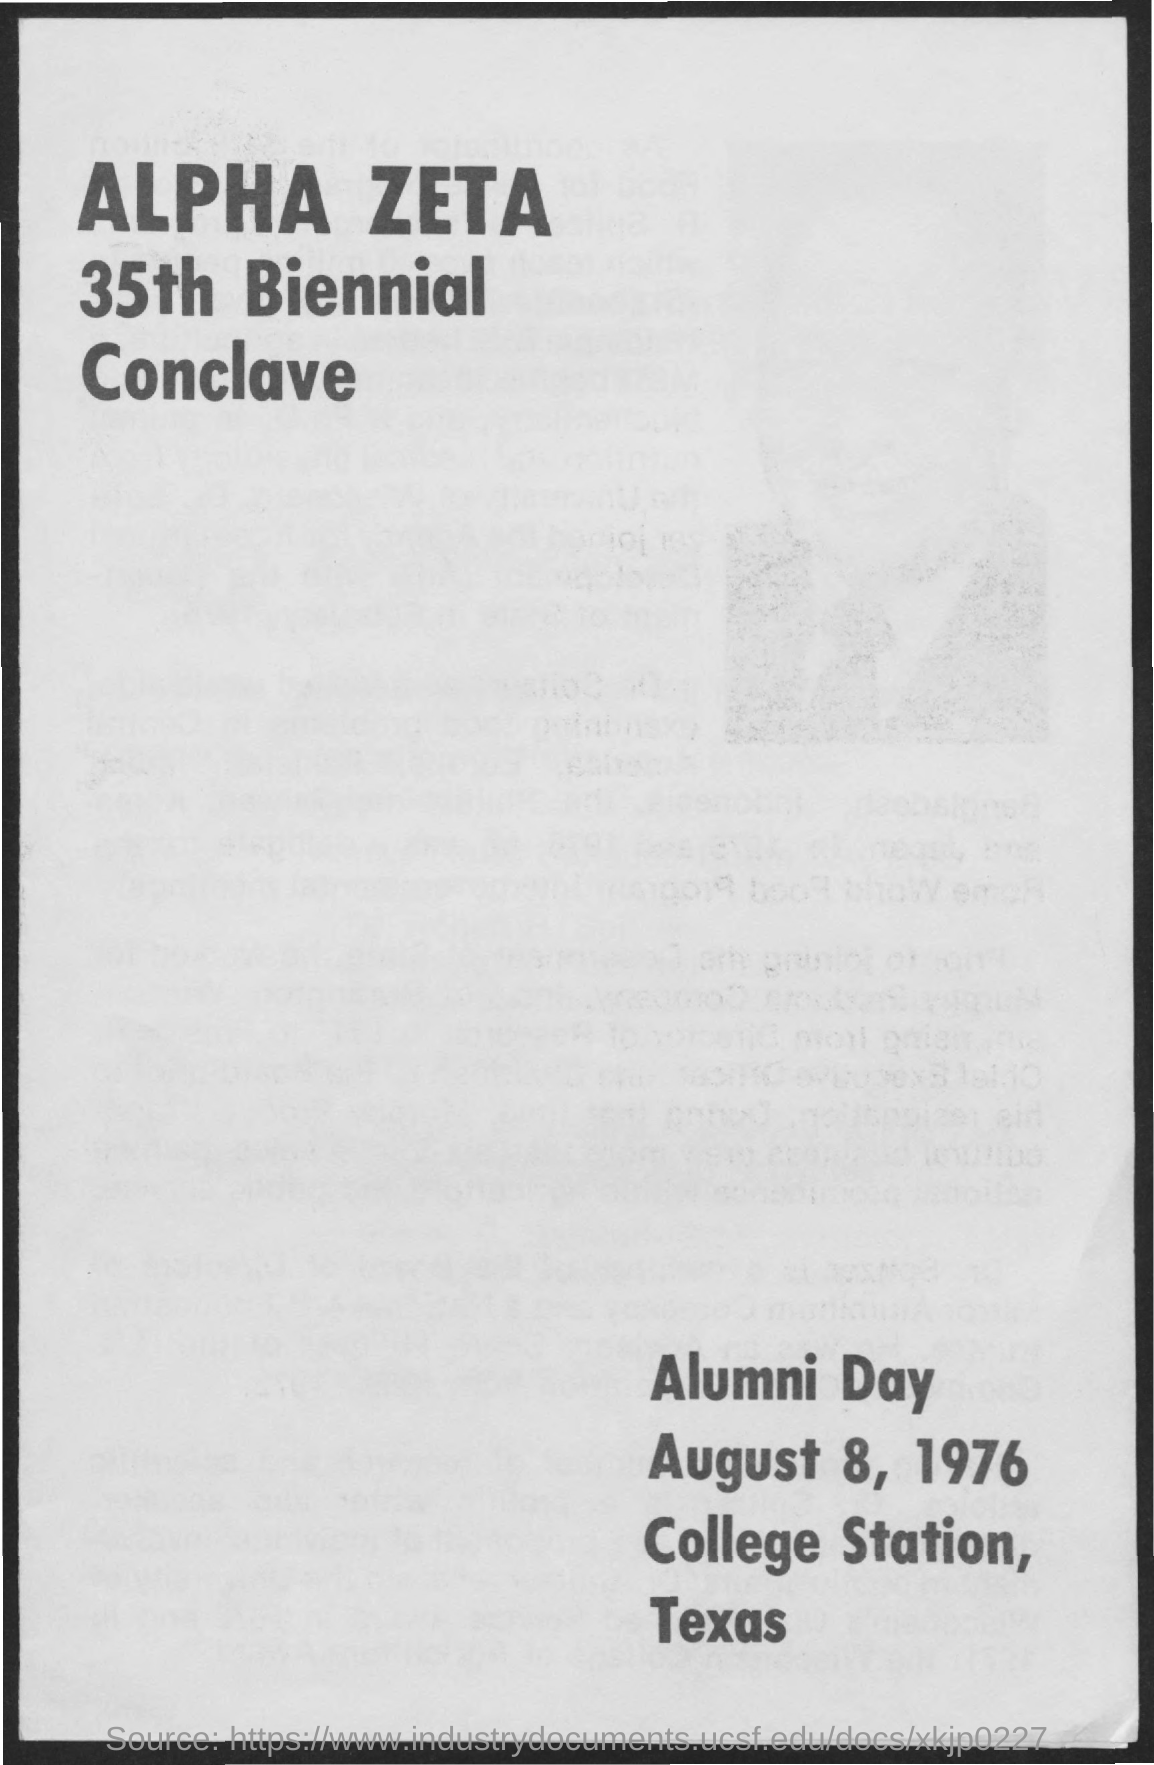Give some essential details in this illustration. The Alpha Zeta 35th Biennial Conclave was held in 1976. August 8, 1976, is the Alumni Day. August is the month that is mentioned in the page. The name of the Conclave is Alpha Zeta. The location of Alumni Day is College Station, Texas. 